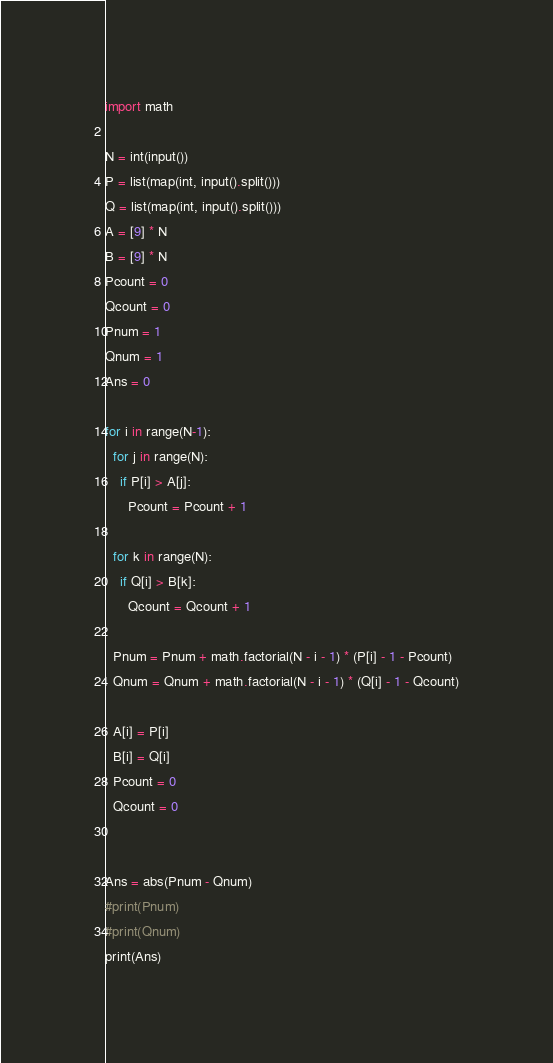Convert code to text. <code><loc_0><loc_0><loc_500><loc_500><_Python_>import math

N = int(input())
P = list(map(int, input().split()))
Q = list(map(int, input().split()))
A = [9] * N
B = [9] * N
Pcount = 0
Qcount = 0
Pnum = 1
Qnum = 1
Ans = 0

for i in range(N-1):
  for j in range(N):
    if P[i] > A[j]:
      Pcount = Pcount + 1
  
  for k in range(N):
    if Q[i] > B[k]:
      Qcount = Qcount + 1
    
  Pnum = Pnum + math.factorial(N - i - 1) * (P[i] - 1 - Pcount)
  Qnum = Qnum + math.factorial(N - i - 1) * (Q[i] - 1 - Qcount)
  
  A[i] = P[i]
  B[i] = Q[i]
  Pcount = 0
  Qcount = 0


Ans = abs(Pnum - Qnum)
#print(Pnum)
#print(Qnum)
print(Ans)</code> 